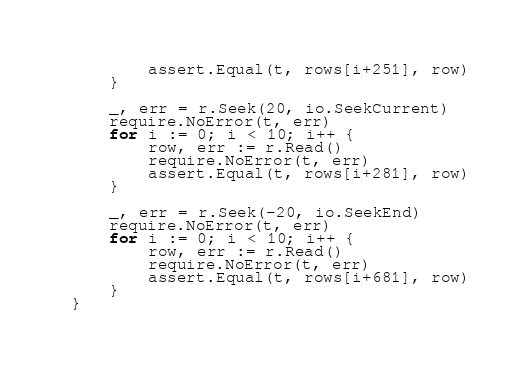<code> <loc_0><loc_0><loc_500><loc_500><_Go_>		assert.Equal(t, rows[i+251], row)
	}

	_, err = r.Seek(20, io.SeekCurrent)
	require.NoError(t, err)
	for i := 0; i < 10; i++ {
		row, err := r.Read()
		require.NoError(t, err)
		assert.Equal(t, rows[i+281], row)
	}

	_, err = r.Seek(-20, io.SeekEnd)
	require.NoError(t, err)
	for i := 0; i < 10; i++ {
		row, err := r.Read()
		require.NoError(t, err)
		assert.Equal(t, rows[i+681], row)
	}
}
</code> 